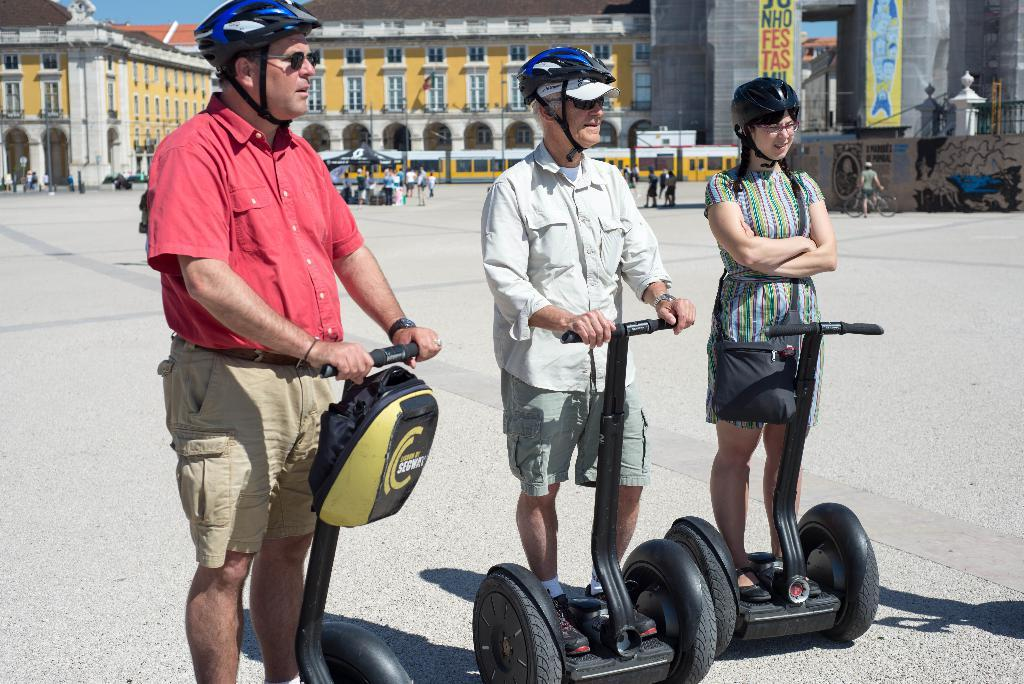What are the people in the foreground of the image doing? The people in the foreground of the image are standing by holding segways. What can be seen in the background of the image? There are buildings visible in the background of the image. Are there any other people in the image besides those in the foreground? Yes, there are many other people in the background of the image. What trail are the people following in the image? There is no trail visible in the image; the people are simply standing by holding segways. What point is the person in the foreground trying to make with their segway? The image does not provide any information about the people's intentions or points they might be trying to make. 